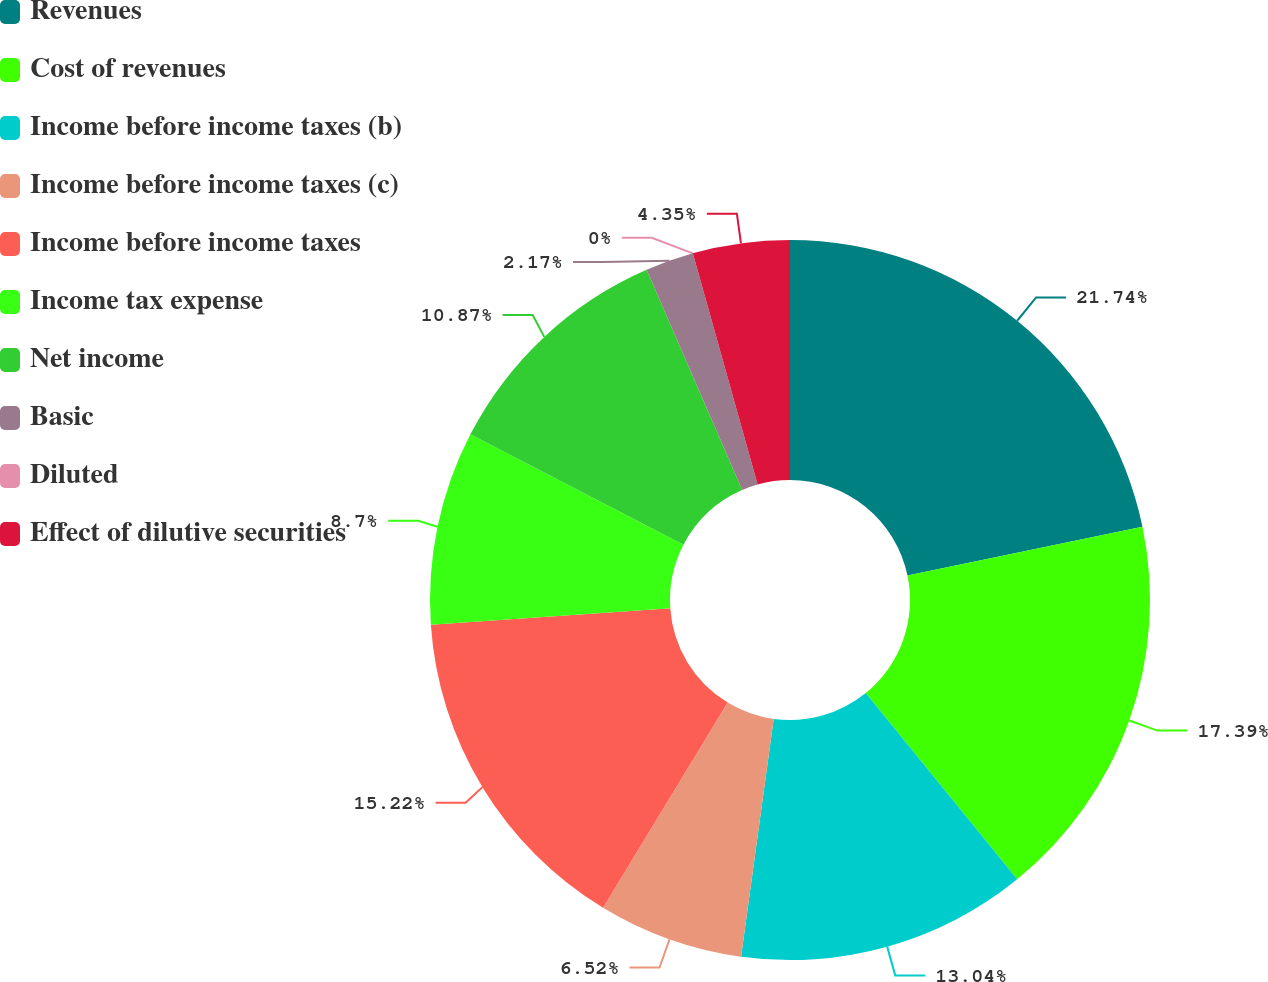<chart> <loc_0><loc_0><loc_500><loc_500><pie_chart><fcel>Revenues<fcel>Cost of revenues<fcel>Income before income taxes (b)<fcel>Income before income taxes (c)<fcel>Income before income taxes<fcel>Income tax expense<fcel>Net income<fcel>Basic<fcel>Diluted<fcel>Effect of dilutive securities<nl><fcel>21.74%<fcel>17.39%<fcel>13.04%<fcel>6.52%<fcel>15.22%<fcel>8.7%<fcel>10.87%<fcel>2.17%<fcel>0.0%<fcel>4.35%<nl></chart> 